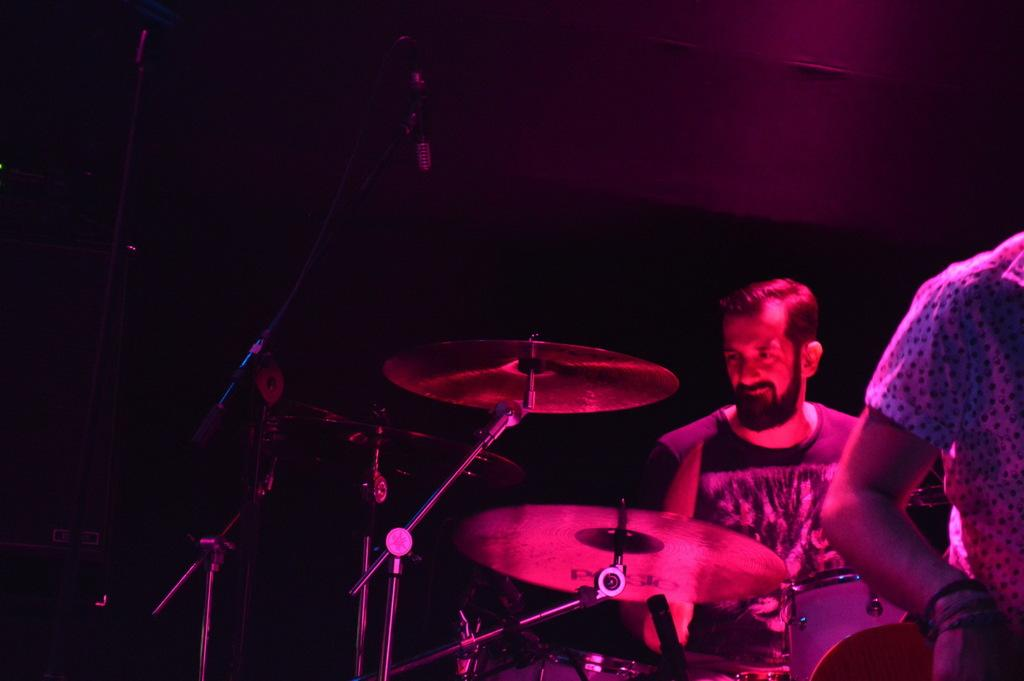What is the man in the image doing? The man is sitting in the image. What objects are in front of the man? There are cymbals and stands in front of the man. Who else is present in the image? There is a person standing in the image. What can be observed about the background of the image? The background of the image is dark. Where is the kitty playing with a ball of light in the image? There is no kitty or ball of light present in the image. 